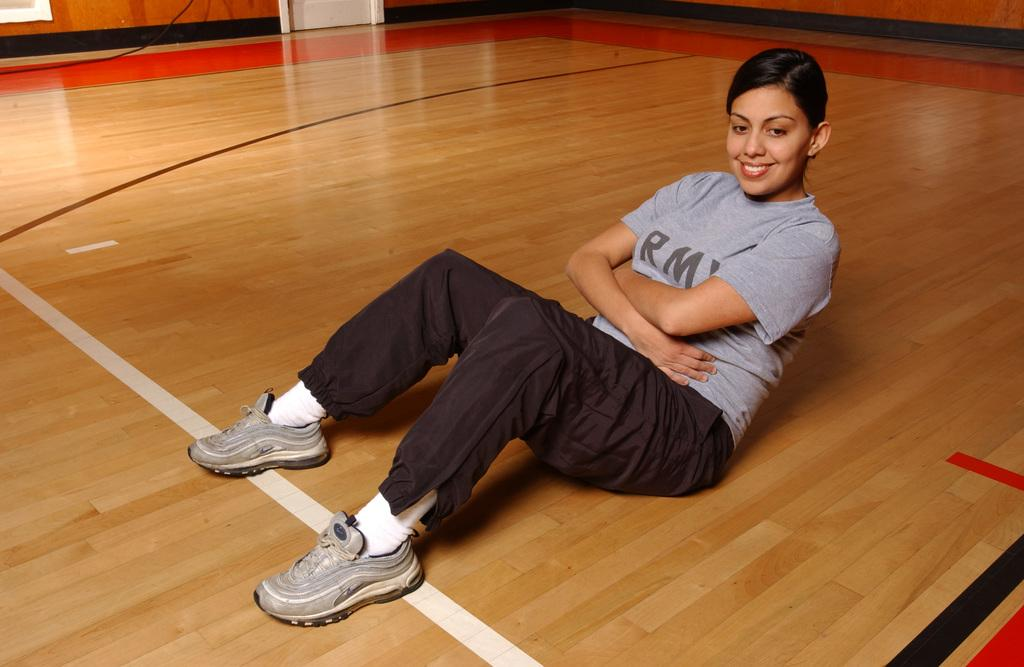Who is present in the image? There is a woman in the picture. What is the woman doing in the image? The woman is seated on the floor. What expression does the woman have in the image? The woman has a smile on her face. What type of bomb is the woman holding in the image? There is no bomb present in the image; the woman is simply seated on the floor with a smile on her face. 